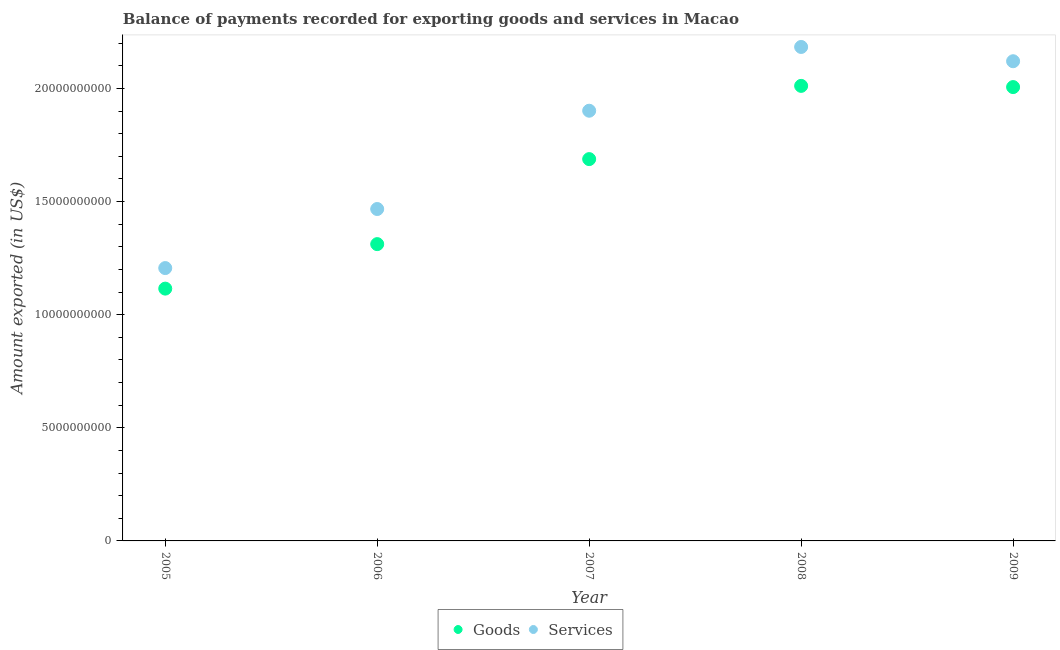What is the amount of services exported in 2006?
Your response must be concise. 1.47e+1. Across all years, what is the maximum amount of goods exported?
Keep it short and to the point. 2.01e+1. Across all years, what is the minimum amount of services exported?
Your answer should be compact. 1.21e+1. What is the total amount of goods exported in the graph?
Your response must be concise. 8.13e+1. What is the difference between the amount of goods exported in 2005 and that in 2007?
Ensure brevity in your answer.  -5.73e+09. What is the difference between the amount of goods exported in 2005 and the amount of services exported in 2009?
Ensure brevity in your answer.  -1.01e+1. What is the average amount of services exported per year?
Offer a terse response. 1.78e+1. In the year 2008, what is the difference between the amount of services exported and amount of goods exported?
Your answer should be compact. 1.72e+09. In how many years, is the amount of services exported greater than 12000000000 US$?
Your answer should be very brief. 5. What is the ratio of the amount of goods exported in 2006 to that in 2008?
Offer a very short reply. 0.65. Is the amount of goods exported in 2005 less than that in 2006?
Keep it short and to the point. Yes. Is the difference between the amount of services exported in 2006 and 2007 greater than the difference between the amount of goods exported in 2006 and 2007?
Your answer should be compact. No. What is the difference between the highest and the second highest amount of goods exported?
Your response must be concise. 5.32e+07. What is the difference between the highest and the lowest amount of goods exported?
Offer a terse response. 8.96e+09. Is the sum of the amount of services exported in 2008 and 2009 greater than the maximum amount of goods exported across all years?
Ensure brevity in your answer.  Yes. Is the amount of goods exported strictly greater than the amount of services exported over the years?
Keep it short and to the point. No. How many dotlines are there?
Offer a very short reply. 2. How many years are there in the graph?
Your answer should be compact. 5. What is the title of the graph?
Give a very brief answer. Balance of payments recorded for exporting goods and services in Macao. What is the label or title of the X-axis?
Keep it short and to the point. Year. What is the label or title of the Y-axis?
Keep it short and to the point. Amount exported (in US$). What is the Amount exported (in US$) in Goods in 2005?
Ensure brevity in your answer.  1.12e+1. What is the Amount exported (in US$) in Services in 2005?
Keep it short and to the point. 1.21e+1. What is the Amount exported (in US$) in Goods in 2006?
Ensure brevity in your answer.  1.31e+1. What is the Amount exported (in US$) of Services in 2006?
Make the answer very short. 1.47e+1. What is the Amount exported (in US$) in Goods in 2007?
Provide a succinct answer. 1.69e+1. What is the Amount exported (in US$) of Services in 2007?
Keep it short and to the point. 1.90e+1. What is the Amount exported (in US$) of Goods in 2008?
Your response must be concise. 2.01e+1. What is the Amount exported (in US$) of Services in 2008?
Offer a very short reply. 2.18e+1. What is the Amount exported (in US$) of Goods in 2009?
Give a very brief answer. 2.01e+1. What is the Amount exported (in US$) in Services in 2009?
Give a very brief answer. 2.12e+1. Across all years, what is the maximum Amount exported (in US$) in Goods?
Your answer should be compact. 2.01e+1. Across all years, what is the maximum Amount exported (in US$) in Services?
Make the answer very short. 2.18e+1. Across all years, what is the minimum Amount exported (in US$) of Goods?
Offer a very short reply. 1.12e+1. Across all years, what is the minimum Amount exported (in US$) of Services?
Make the answer very short. 1.21e+1. What is the total Amount exported (in US$) in Goods in the graph?
Your answer should be very brief. 8.13e+1. What is the total Amount exported (in US$) of Services in the graph?
Provide a short and direct response. 8.88e+1. What is the difference between the Amount exported (in US$) in Goods in 2005 and that in 2006?
Keep it short and to the point. -1.97e+09. What is the difference between the Amount exported (in US$) of Services in 2005 and that in 2006?
Ensure brevity in your answer.  -2.61e+09. What is the difference between the Amount exported (in US$) of Goods in 2005 and that in 2007?
Give a very brief answer. -5.73e+09. What is the difference between the Amount exported (in US$) in Services in 2005 and that in 2007?
Offer a very short reply. -6.96e+09. What is the difference between the Amount exported (in US$) of Goods in 2005 and that in 2008?
Your answer should be very brief. -8.96e+09. What is the difference between the Amount exported (in US$) in Services in 2005 and that in 2008?
Offer a very short reply. -9.78e+09. What is the difference between the Amount exported (in US$) in Goods in 2005 and that in 2009?
Give a very brief answer. -8.91e+09. What is the difference between the Amount exported (in US$) of Services in 2005 and that in 2009?
Offer a very short reply. -9.14e+09. What is the difference between the Amount exported (in US$) of Goods in 2006 and that in 2007?
Your answer should be very brief. -3.76e+09. What is the difference between the Amount exported (in US$) of Services in 2006 and that in 2007?
Offer a terse response. -4.35e+09. What is the difference between the Amount exported (in US$) of Goods in 2006 and that in 2008?
Keep it short and to the point. -7.00e+09. What is the difference between the Amount exported (in US$) of Services in 2006 and that in 2008?
Make the answer very short. -7.16e+09. What is the difference between the Amount exported (in US$) of Goods in 2006 and that in 2009?
Your answer should be compact. -6.94e+09. What is the difference between the Amount exported (in US$) in Services in 2006 and that in 2009?
Keep it short and to the point. -6.53e+09. What is the difference between the Amount exported (in US$) of Goods in 2007 and that in 2008?
Give a very brief answer. -3.24e+09. What is the difference between the Amount exported (in US$) of Services in 2007 and that in 2008?
Your answer should be very brief. -2.82e+09. What is the difference between the Amount exported (in US$) of Goods in 2007 and that in 2009?
Offer a very short reply. -3.18e+09. What is the difference between the Amount exported (in US$) of Services in 2007 and that in 2009?
Provide a short and direct response. -2.19e+09. What is the difference between the Amount exported (in US$) of Goods in 2008 and that in 2009?
Your answer should be compact. 5.32e+07. What is the difference between the Amount exported (in US$) of Services in 2008 and that in 2009?
Keep it short and to the point. 6.31e+08. What is the difference between the Amount exported (in US$) in Goods in 2005 and the Amount exported (in US$) in Services in 2006?
Your answer should be very brief. -3.52e+09. What is the difference between the Amount exported (in US$) of Goods in 2005 and the Amount exported (in US$) of Services in 2007?
Give a very brief answer. -7.86e+09. What is the difference between the Amount exported (in US$) of Goods in 2005 and the Amount exported (in US$) of Services in 2008?
Your answer should be compact. -1.07e+1. What is the difference between the Amount exported (in US$) in Goods in 2005 and the Amount exported (in US$) in Services in 2009?
Offer a very short reply. -1.01e+1. What is the difference between the Amount exported (in US$) of Goods in 2006 and the Amount exported (in US$) of Services in 2007?
Ensure brevity in your answer.  -5.90e+09. What is the difference between the Amount exported (in US$) in Goods in 2006 and the Amount exported (in US$) in Services in 2008?
Keep it short and to the point. -8.72e+09. What is the difference between the Amount exported (in US$) of Goods in 2006 and the Amount exported (in US$) of Services in 2009?
Your answer should be very brief. -8.09e+09. What is the difference between the Amount exported (in US$) in Goods in 2007 and the Amount exported (in US$) in Services in 2008?
Make the answer very short. -4.96e+09. What is the difference between the Amount exported (in US$) in Goods in 2007 and the Amount exported (in US$) in Services in 2009?
Your response must be concise. -4.33e+09. What is the difference between the Amount exported (in US$) of Goods in 2008 and the Amount exported (in US$) of Services in 2009?
Give a very brief answer. -1.09e+09. What is the average Amount exported (in US$) of Goods per year?
Your answer should be compact. 1.63e+1. What is the average Amount exported (in US$) in Services per year?
Offer a terse response. 1.78e+1. In the year 2005, what is the difference between the Amount exported (in US$) in Goods and Amount exported (in US$) in Services?
Provide a short and direct response. -9.08e+08. In the year 2006, what is the difference between the Amount exported (in US$) in Goods and Amount exported (in US$) in Services?
Give a very brief answer. -1.55e+09. In the year 2007, what is the difference between the Amount exported (in US$) of Goods and Amount exported (in US$) of Services?
Your answer should be very brief. -2.14e+09. In the year 2008, what is the difference between the Amount exported (in US$) in Goods and Amount exported (in US$) in Services?
Provide a short and direct response. -1.72e+09. In the year 2009, what is the difference between the Amount exported (in US$) in Goods and Amount exported (in US$) in Services?
Your response must be concise. -1.14e+09. What is the ratio of the Amount exported (in US$) in Goods in 2005 to that in 2006?
Keep it short and to the point. 0.85. What is the ratio of the Amount exported (in US$) of Services in 2005 to that in 2006?
Your response must be concise. 0.82. What is the ratio of the Amount exported (in US$) of Goods in 2005 to that in 2007?
Your answer should be compact. 0.66. What is the ratio of the Amount exported (in US$) of Services in 2005 to that in 2007?
Your answer should be compact. 0.63. What is the ratio of the Amount exported (in US$) in Goods in 2005 to that in 2008?
Your answer should be very brief. 0.55. What is the ratio of the Amount exported (in US$) in Services in 2005 to that in 2008?
Give a very brief answer. 0.55. What is the ratio of the Amount exported (in US$) of Goods in 2005 to that in 2009?
Keep it short and to the point. 0.56. What is the ratio of the Amount exported (in US$) in Services in 2005 to that in 2009?
Your answer should be very brief. 0.57. What is the ratio of the Amount exported (in US$) in Goods in 2006 to that in 2007?
Make the answer very short. 0.78. What is the ratio of the Amount exported (in US$) in Services in 2006 to that in 2007?
Offer a terse response. 0.77. What is the ratio of the Amount exported (in US$) of Goods in 2006 to that in 2008?
Offer a terse response. 0.65. What is the ratio of the Amount exported (in US$) in Services in 2006 to that in 2008?
Your response must be concise. 0.67. What is the ratio of the Amount exported (in US$) of Goods in 2006 to that in 2009?
Offer a very short reply. 0.65. What is the ratio of the Amount exported (in US$) of Services in 2006 to that in 2009?
Make the answer very short. 0.69. What is the ratio of the Amount exported (in US$) in Goods in 2007 to that in 2008?
Provide a succinct answer. 0.84. What is the ratio of the Amount exported (in US$) in Services in 2007 to that in 2008?
Offer a very short reply. 0.87. What is the ratio of the Amount exported (in US$) in Goods in 2007 to that in 2009?
Offer a very short reply. 0.84. What is the ratio of the Amount exported (in US$) of Services in 2007 to that in 2009?
Your answer should be compact. 0.9. What is the ratio of the Amount exported (in US$) of Services in 2008 to that in 2009?
Your response must be concise. 1.03. What is the difference between the highest and the second highest Amount exported (in US$) of Goods?
Give a very brief answer. 5.32e+07. What is the difference between the highest and the second highest Amount exported (in US$) in Services?
Offer a terse response. 6.31e+08. What is the difference between the highest and the lowest Amount exported (in US$) in Goods?
Ensure brevity in your answer.  8.96e+09. What is the difference between the highest and the lowest Amount exported (in US$) of Services?
Your answer should be very brief. 9.78e+09. 